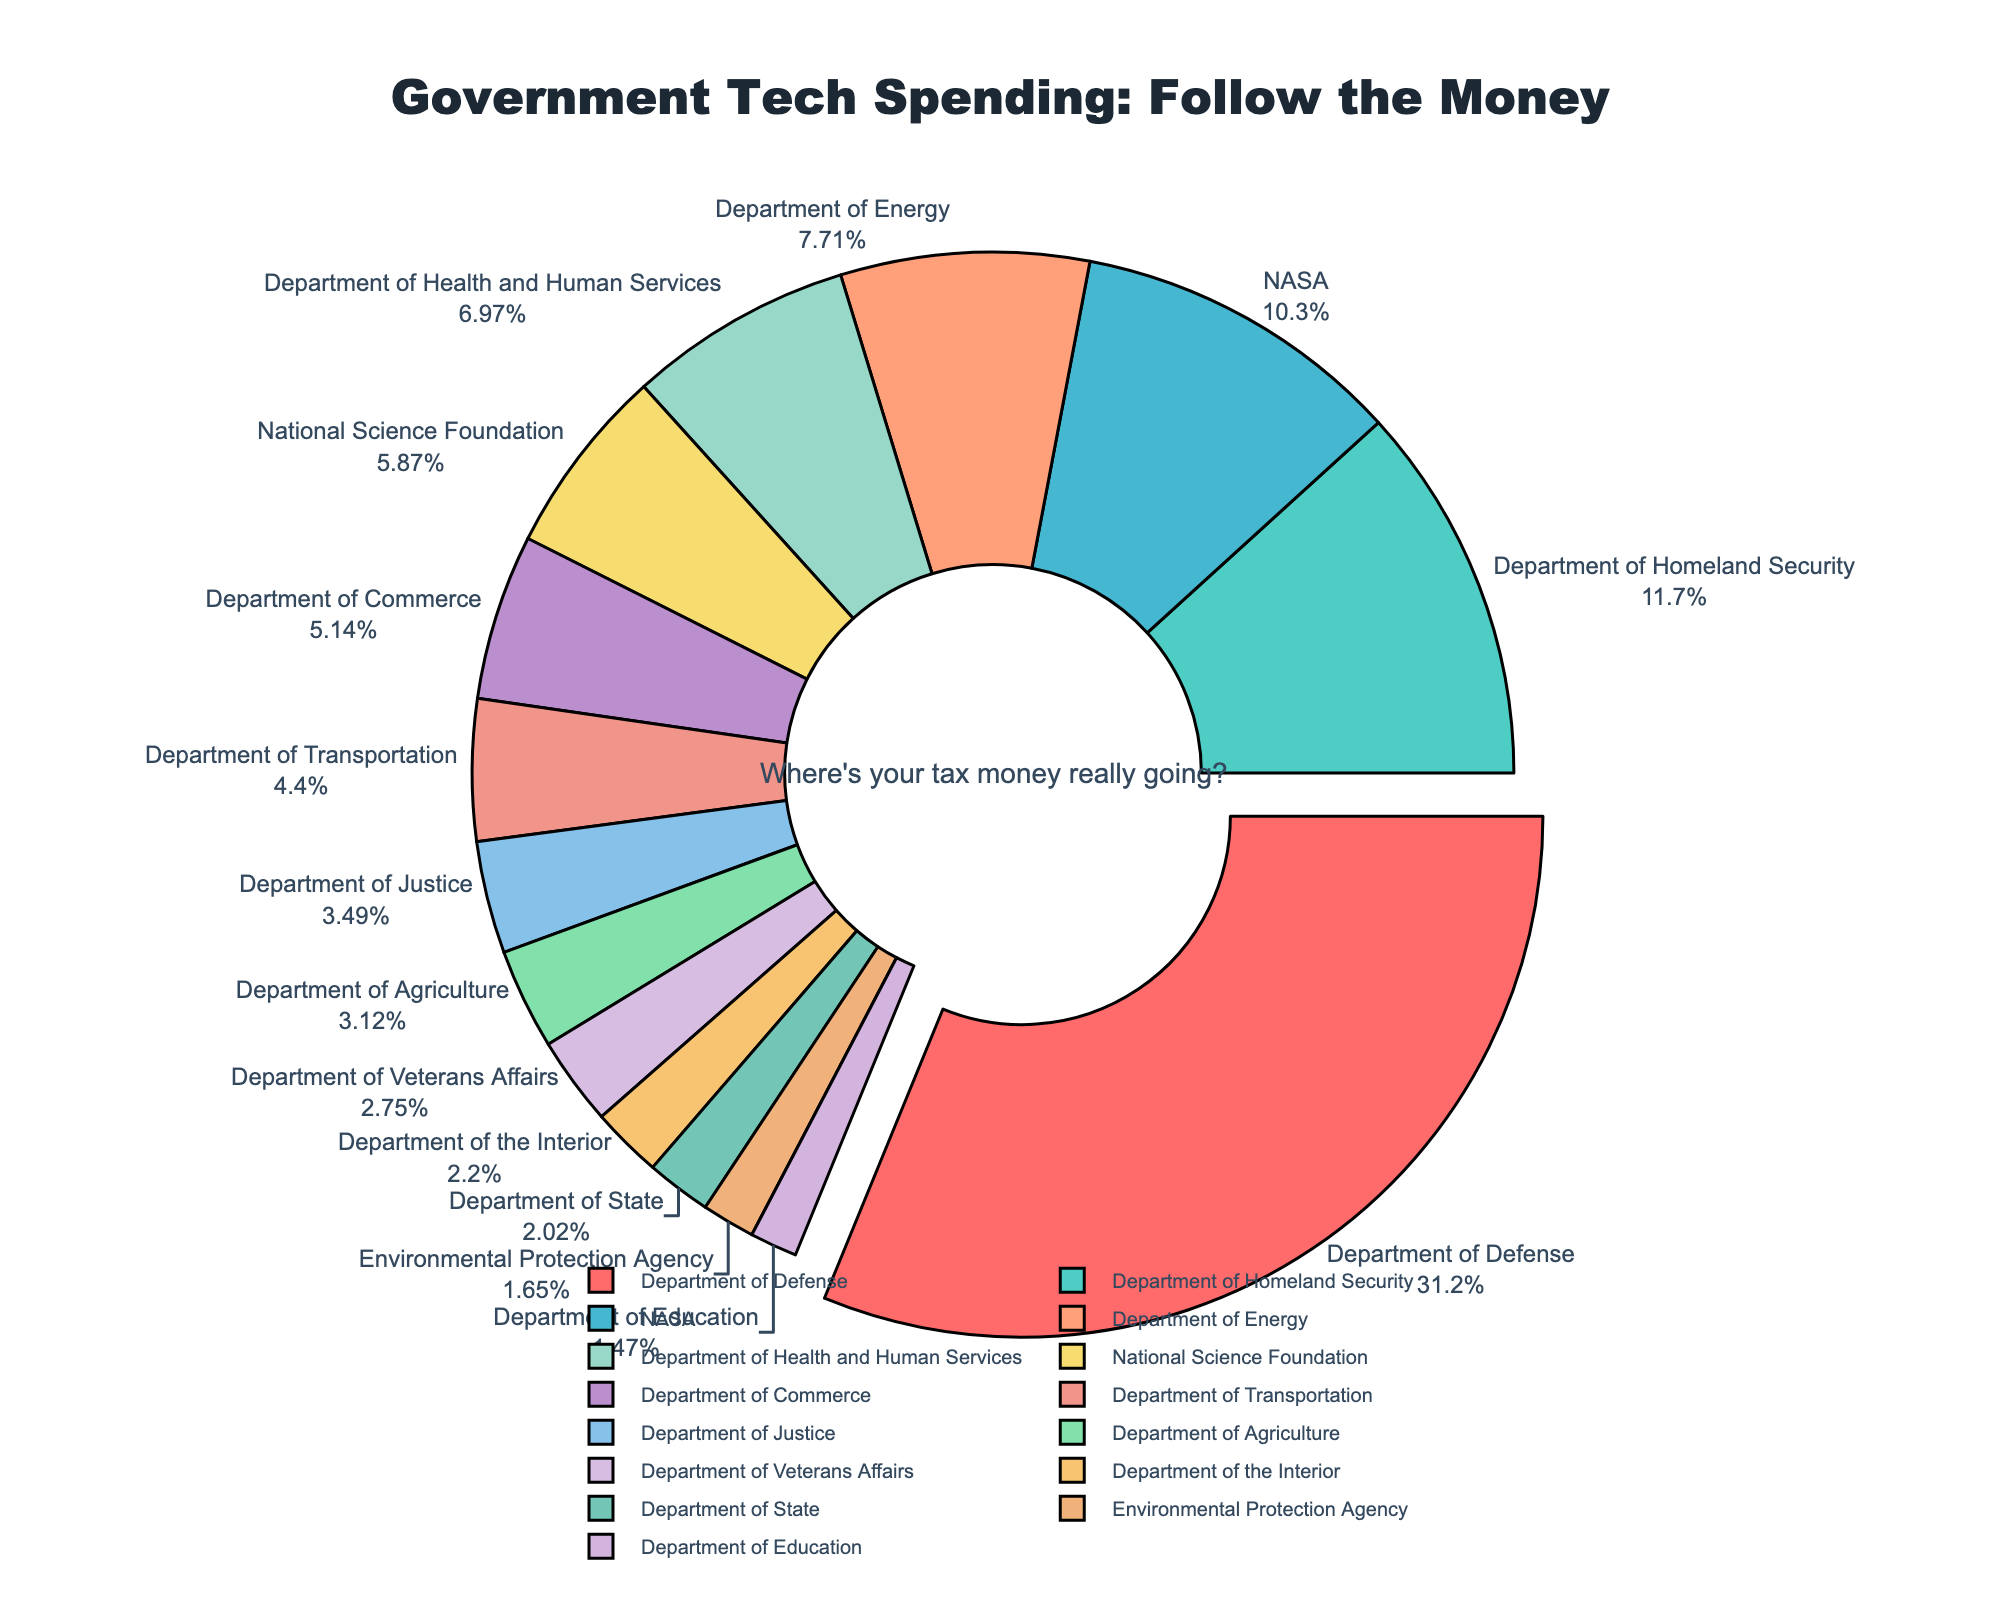What percentage of the total government spending on technology projects is allocated to the Department of Defense? Identify the segment labeled "Department of Defense" in the pie chart, which has a pull-out effect. Note the percentage given next to the label.
Answer: 42.6% Which department receives the second-highest amount of funding? Look at the slice adjacent to the Department of Defense slice, which is labeled "Department of Homeland Security". Verify that it has the second-largest segment.
Answer: Department of Homeland Security Combining the spending of NASA and the Department of Energy, what is their total expenditure? Identify the segments for NASA and the Department of Energy, noting their expenditures (2800 million USD and 2100 million USD, respectively). Sum them up: 2800 + 2100 = 4900 million USD.
Answer: 4900 million USD Is the funding for the Department of Commerce higher or lower than for the Department of Justice? Identify the Department of Commerce and Department of Justice segments. Compare their values: Department of Commerce (1400 million USD) and Department of Justice (950 million USD).
Answer: Higher Which department's segment is colored red in the pie chart? Look for the slice colored in red, following the custom color scale applied. Identify the label next to this slice.
Answer: Department of Defense How much more is allocated to the Department of Homeland Security compared to the Department of Energy? Identify the expenditures for both departments: Department of Homeland Security (3200 million USD) and Department of Energy (2100 million USD). Calculate the difference: 3200 - 2100 = 1100 million USD.
Answer: 1100 million USD Summing the expenditures of the Department of Veterans Affairs and the Department of Interior, do they together sum up to more or less than 2000 million USD? Identify the segments for both departments and their expenditures: Department of Veterans Affairs (750 million USD) and Department of the Interior (600 million USD). Sum them up: 750 + 600 = 1350 million USD.
Answer: Less Which department receives less than 500 million USD in funding but more than 400 million USD? Look for segments with values between 400 and 500 million USD. Identify the department labeled "Environmental Protection Agency" with 450 million USD.
Answer: Environmental Protection Agency What is the combined spending of the Department of Health and Human Services and the Department of Commerce? Identify the expenditures for both departments: Department of Health and Human Services (1900 million USD) and Department of Commerce (1400 million USD). Sum them up: 1900 + 1400 = 3300 million USD.
Answer: 3300 million USD What is the visual effect applied to the Department of Defense segment in the pie chart? The Department of Defense segment stands out with a pull-out effect, making it more visually prominent.
Answer: Pull-out effect 